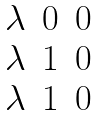Convert formula to latex. <formula><loc_0><loc_0><loc_500><loc_500>\begin{matrix} \lambda & 0 & 0 \\ \lambda & 1 & 0 \\ \lambda & 1 & 0 \end{matrix}</formula> 